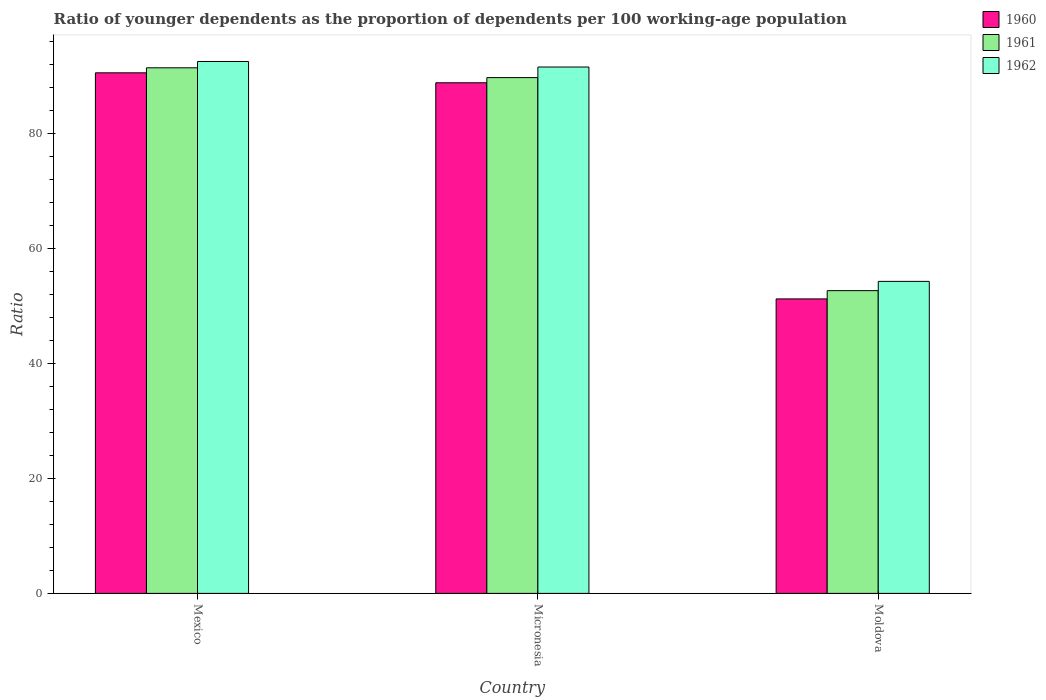How many different coloured bars are there?
Your answer should be compact. 3. How many groups of bars are there?
Your answer should be compact. 3. Are the number of bars per tick equal to the number of legend labels?
Provide a short and direct response. Yes. How many bars are there on the 2nd tick from the right?
Give a very brief answer. 3. What is the label of the 2nd group of bars from the left?
Ensure brevity in your answer.  Micronesia. In how many cases, is the number of bars for a given country not equal to the number of legend labels?
Ensure brevity in your answer.  0. What is the age dependency ratio(young) in 1961 in Micronesia?
Make the answer very short. 89.75. Across all countries, what is the maximum age dependency ratio(young) in 1962?
Offer a very short reply. 92.55. Across all countries, what is the minimum age dependency ratio(young) in 1961?
Provide a succinct answer. 52.68. In which country was the age dependency ratio(young) in 1961 maximum?
Keep it short and to the point. Mexico. In which country was the age dependency ratio(young) in 1962 minimum?
Offer a terse response. Moldova. What is the total age dependency ratio(young) in 1960 in the graph?
Your response must be concise. 230.67. What is the difference between the age dependency ratio(young) in 1960 in Micronesia and that in Moldova?
Your response must be concise. 37.61. What is the difference between the age dependency ratio(young) in 1961 in Mexico and the age dependency ratio(young) in 1962 in Moldova?
Your answer should be very brief. 37.16. What is the average age dependency ratio(young) in 1962 per country?
Your answer should be very brief. 79.48. What is the difference between the age dependency ratio(young) of/in 1962 and age dependency ratio(young) of/in 1960 in Moldova?
Keep it short and to the point. 3.05. What is the ratio of the age dependency ratio(young) in 1960 in Mexico to that in Micronesia?
Your response must be concise. 1.02. What is the difference between the highest and the second highest age dependency ratio(young) in 1960?
Provide a succinct answer. -1.73. What is the difference between the highest and the lowest age dependency ratio(young) in 1960?
Your answer should be very brief. 39.34. In how many countries, is the age dependency ratio(young) in 1961 greater than the average age dependency ratio(young) in 1961 taken over all countries?
Give a very brief answer. 2. What does the 2nd bar from the left in Mexico represents?
Ensure brevity in your answer.  1961. What is the difference between two consecutive major ticks on the Y-axis?
Ensure brevity in your answer.  20. Does the graph contain any zero values?
Offer a very short reply. No. How many legend labels are there?
Provide a succinct answer. 3. What is the title of the graph?
Offer a very short reply. Ratio of younger dependents as the proportion of dependents per 100 working-age population. What is the label or title of the X-axis?
Your answer should be compact. Country. What is the label or title of the Y-axis?
Your answer should be very brief. Ratio. What is the Ratio in 1960 in Mexico?
Provide a short and direct response. 90.58. What is the Ratio in 1961 in Mexico?
Make the answer very short. 91.45. What is the Ratio of 1962 in Mexico?
Make the answer very short. 92.55. What is the Ratio of 1960 in Micronesia?
Keep it short and to the point. 88.85. What is the Ratio of 1961 in Micronesia?
Your answer should be very brief. 89.75. What is the Ratio in 1962 in Micronesia?
Your response must be concise. 91.59. What is the Ratio in 1960 in Moldova?
Provide a succinct answer. 51.24. What is the Ratio of 1961 in Moldova?
Provide a succinct answer. 52.68. What is the Ratio of 1962 in Moldova?
Offer a terse response. 54.29. Across all countries, what is the maximum Ratio in 1960?
Provide a short and direct response. 90.58. Across all countries, what is the maximum Ratio of 1961?
Offer a very short reply. 91.45. Across all countries, what is the maximum Ratio in 1962?
Provide a short and direct response. 92.55. Across all countries, what is the minimum Ratio of 1960?
Ensure brevity in your answer.  51.24. Across all countries, what is the minimum Ratio in 1961?
Your answer should be very brief. 52.68. Across all countries, what is the minimum Ratio of 1962?
Provide a short and direct response. 54.29. What is the total Ratio in 1960 in the graph?
Your answer should be very brief. 230.67. What is the total Ratio in 1961 in the graph?
Ensure brevity in your answer.  233.88. What is the total Ratio in 1962 in the graph?
Give a very brief answer. 238.43. What is the difference between the Ratio in 1960 in Mexico and that in Micronesia?
Offer a terse response. 1.73. What is the difference between the Ratio in 1961 in Mexico and that in Micronesia?
Your answer should be compact. 1.7. What is the difference between the Ratio of 1962 in Mexico and that in Micronesia?
Keep it short and to the point. 0.97. What is the difference between the Ratio of 1960 in Mexico and that in Moldova?
Ensure brevity in your answer.  39.34. What is the difference between the Ratio of 1961 in Mexico and that in Moldova?
Provide a succinct answer. 38.77. What is the difference between the Ratio in 1962 in Mexico and that in Moldova?
Make the answer very short. 38.27. What is the difference between the Ratio in 1960 in Micronesia and that in Moldova?
Your answer should be very brief. 37.61. What is the difference between the Ratio of 1961 in Micronesia and that in Moldova?
Offer a very short reply. 37.07. What is the difference between the Ratio in 1962 in Micronesia and that in Moldova?
Make the answer very short. 37.3. What is the difference between the Ratio in 1960 in Mexico and the Ratio in 1961 in Micronesia?
Offer a terse response. 0.83. What is the difference between the Ratio of 1960 in Mexico and the Ratio of 1962 in Micronesia?
Provide a succinct answer. -1.01. What is the difference between the Ratio of 1961 in Mexico and the Ratio of 1962 in Micronesia?
Your response must be concise. -0.14. What is the difference between the Ratio of 1960 in Mexico and the Ratio of 1961 in Moldova?
Give a very brief answer. 37.9. What is the difference between the Ratio in 1960 in Mexico and the Ratio in 1962 in Moldova?
Your response must be concise. 36.29. What is the difference between the Ratio in 1961 in Mexico and the Ratio in 1962 in Moldova?
Make the answer very short. 37.16. What is the difference between the Ratio in 1960 in Micronesia and the Ratio in 1961 in Moldova?
Ensure brevity in your answer.  36.17. What is the difference between the Ratio in 1960 in Micronesia and the Ratio in 1962 in Moldova?
Offer a terse response. 34.56. What is the difference between the Ratio in 1961 in Micronesia and the Ratio in 1962 in Moldova?
Offer a terse response. 35.46. What is the average Ratio in 1960 per country?
Ensure brevity in your answer.  76.89. What is the average Ratio of 1961 per country?
Your response must be concise. 77.96. What is the average Ratio in 1962 per country?
Your response must be concise. 79.48. What is the difference between the Ratio of 1960 and Ratio of 1961 in Mexico?
Your answer should be very brief. -0.87. What is the difference between the Ratio of 1960 and Ratio of 1962 in Mexico?
Make the answer very short. -1.97. What is the difference between the Ratio in 1961 and Ratio in 1962 in Mexico?
Provide a short and direct response. -1.1. What is the difference between the Ratio in 1960 and Ratio in 1961 in Micronesia?
Offer a very short reply. -0.9. What is the difference between the Ratio of 1960 and Ratio of 1962 in Micronesia?
Offer a very short reply. -2.74. What is the difference between the Ratio of 1961 and Ratio of 1962 in Micronesia?
Your response must be concise. -1.84. What is the difference between the Ratio of 1960 and Ratio of 1961 in Moldova?
Your response must be concise. -1.44. What is the difference between the Ratio in 1960 and Ratio in 1962 in Moldova?
Your answer should be compact. -3.05. What is the difference between the Ratio of 1961 and Ratio of 1962 in Moldova?
Provide a succinct answer. -1.61. What is the ratio of the Ratio in 1960 in Mexico to that in Micronesia?
Your answer should be compact. 1.02. What is the ratio of the Ratio in 1962 in Mexico to that in Micronesia?
Offer a very short reply. 1.01. What is the ratio of the Ratio in 1960 in Mexico to that in Moldova?
Keep it short and to the point. 1.77. What is the ratio of the Ratio of 1961 in Mexico to that in Moldova?
Keep it short and to the point. 1.74. What is the ratio of the Ratio of 1962 in Mexico to that in Moldova?
Your response must be concise. 1.7. What is the ratio of the Ratio in 1960 in Micronesia to that in Moldova?
Your response must be concise. 1.73. What is the ratio of the Ratio in 1961 in Micronesia to that in Moldova?
Your response must be concise. 1.7. What is the ratio of the Ratio in 1962 in Micronesia to that in Moldova?
Ensure brevity in your answer.  1.69. What is the difference between the highest and the second highest Ratio of 1960?
Give a very brief answer. 1.73. What is the difference between the highest and the second highest Ratio of 1961?
Keep it short and to the point. 1.7. What is the difference between the highest and the second highest Ratio in 1962?
Provide a succinct answer. 0.97. What is the difference between the highest and the lowest Ratio in 1960?
Give a very brief answer. 39.34. What is the difference between the highest and the lowest Ratio of 1961?
Provide a succinct answer. 38.77. What is the difference between the highest and the lowest Ratio in 1962?
Keep it short and to the point. 38.27. 